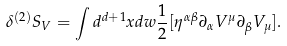Convert formula to latex. <formula><loc_0><loc_0><loc_500><loc_500>\delta ^ { ( 2 ) } S _ { V } = \int d ^ { d + 1 } x d w \frac { 1 } { 2 } [ \eta ^ { \alpha \beta } \partial _ { \alpha } V ^ { \mu } \partial _ { \beta } V _ { \mu } ] .</formula> 